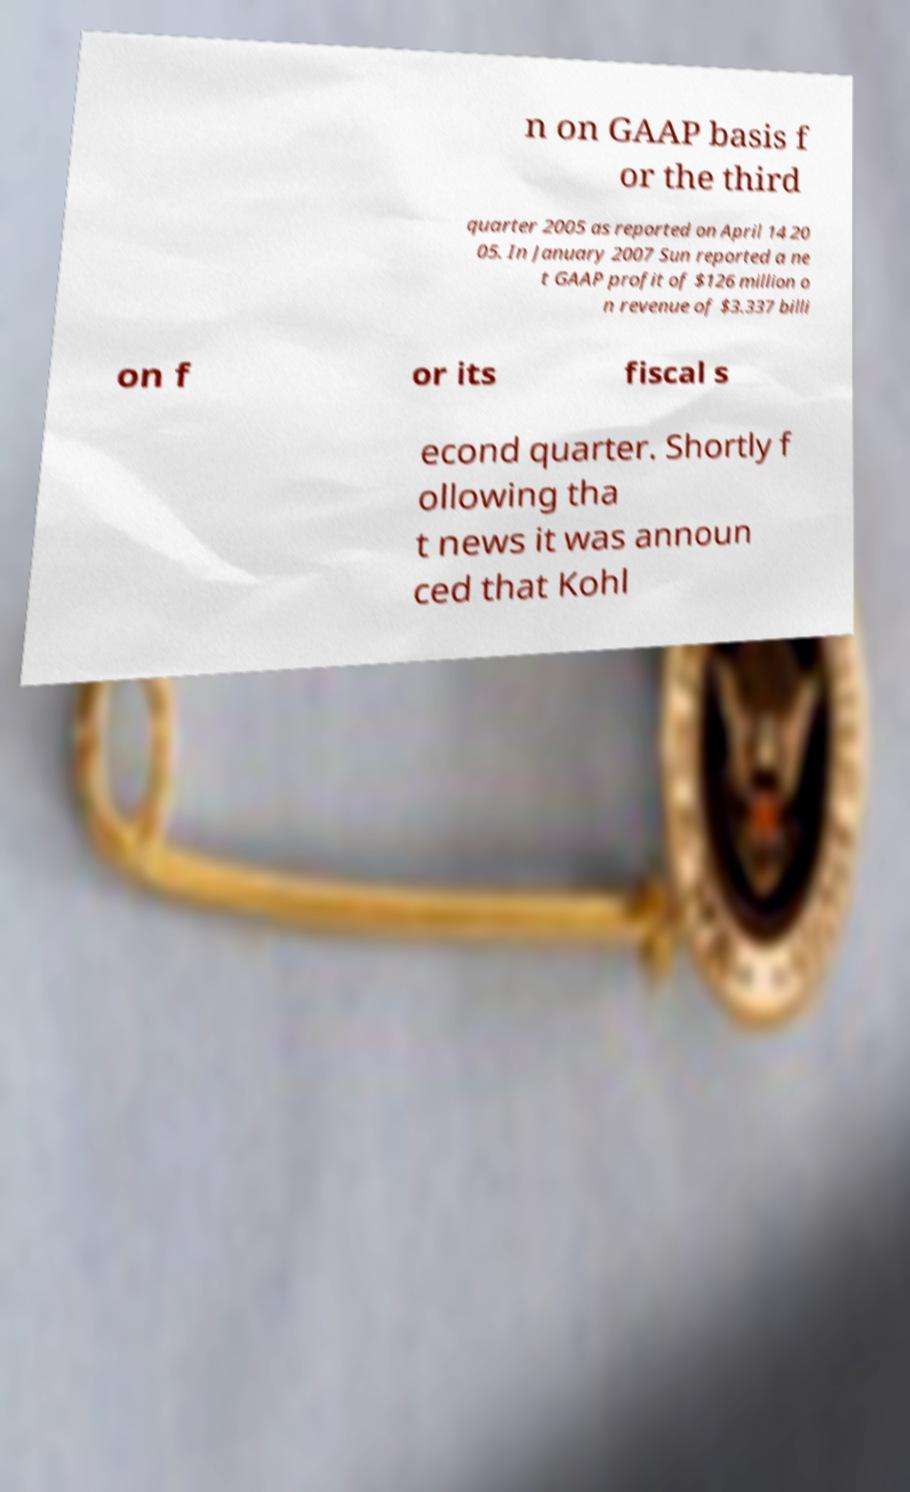I need the written content from this picture converted into text. Can you do that? n on GAAP basis f or the third quarter 2005 as reported on April 14 20 05. In January 2007 Sun reported a ne t GAAP profit of $126 million o n revenue of $3.337 billi on f or its fiscal s econd quarter. Shortly f ollowing tha t news it was announ ced that Kohl 